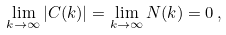Convert formula to latex. <formula><loc_0><loc_0><loc_500><loc_500>\lim _ { k \rightarrow \infty } | C ( k ) | = \lim _ { k \rightarrow \infty } N ( k ) = 0 \, ,</formula> 